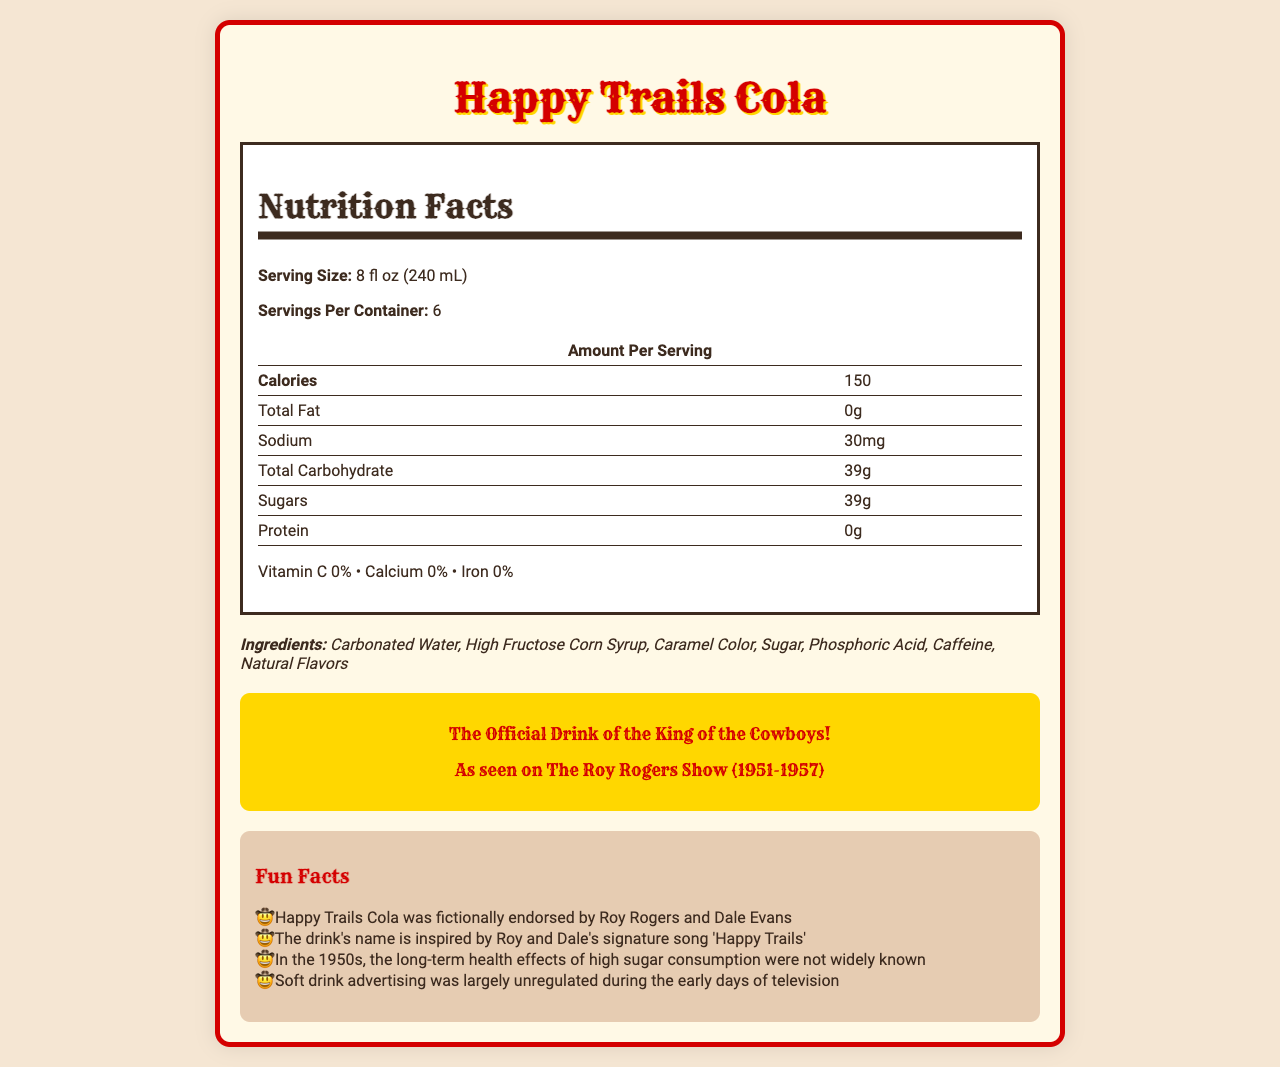what is the calorie content per serving of Happy Trails Cola? The document lists the calorie content per serving as 150 calories under the "Amount Per Serving" section.
Answer: 150 calories how many grams of sugar are in an 8 fl oz serving? According to the "Sugars" row in the Nutrition Facts table, there are 39 grams of sugars per serving.
Answer: 39 grams what is the serving size for Happy Trails Cola? The serving size is mentioned at the top of the Nutrition Facts, specified as 8 fl oz (240 mL).
Answer: 8 fl oz (240 mL) what is the primary ingredient in Happy Trails Cola? The first item listed in the ingredients section is Carbonated Water, indicating it is the primary ingredient.
Answer: Carbonated Water how many servings are in a container of Happy Trails Cola? The document states that there are six servings per container.
Answer: 6 servings which of the following is not an ingredient in Happy Trails Cola: A. Caffeine, B. Phosphoric Acid, C. Aspartame, D. Caramel Color The ingredients listed are Carbonated Water, High Fructose Corn Syrup, Caramel Color, Sugar, Phosphoric Acid, Caffeine, and Natural Flavors. Aspartame is not included.
Answer: C. Aspartame during which television show was Happy Trails Cola advertised? A. Gunsmoke, B. The Roy Rogers Show, C. Bonanza, D. The Lone Ranger The historical context section mentions that Happy Trails Cola was advertised on "The Roy Rogers Show."
Answer: B. The Roy Rogers Show is there any protein in Happy Trails Cola? According to the Nutrition Facts table, the amount of protein per serving is 0g.
Answer: No does Happy Trails Cola provide any vitamin C? The document specifies that Vitamin C is 0%, indicating no vitamin C content.
Answer: No summarize the main idea of the document. This summary captures the primary content areas of the document, including nutrition, historical context, and design elements.
Answer: The document provides a detailed overview of Happy Trails Cola, including its nutritional facts, ingredients, historical context, and vintage advertising elements. It was a soda advertised during "The Roy Rogers Show" in the 1950s, contains 150 calories and 39 grams of sugar per serving, and has a vintage design inspired by western themes. what is the total carbohydrate content per serving? The total carbohydrate content per serving is listed as 39 grams in the Nutrition Facts table.
Answer: 39 grams how many options are used to answer the binary (yes/no) question in the document? The document doesn't specify the number of options for answering the binary question.
Answer: Not enough information 